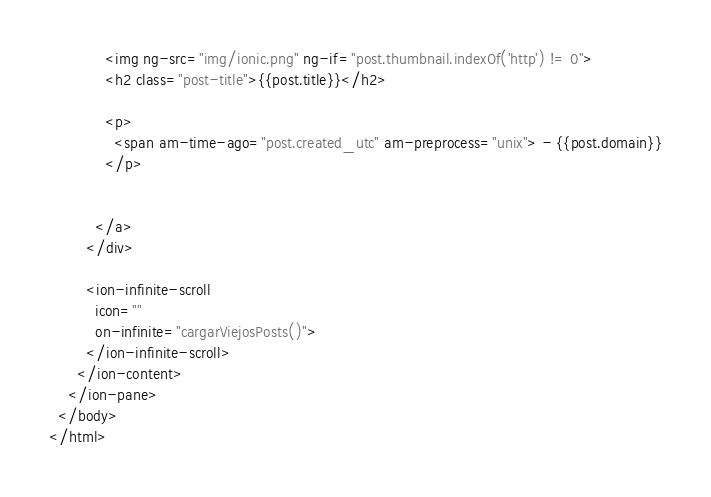<code> <loc_0><loc_0><loc_500><loc_500><_HTML_>            <img ng-src="img/ionic.png" ng-if="post.thumbnail.indexOf('http') != 0">
            <h2 class="post-title">{{post.title}}</h2>

            <p>
              <span am-time-ago="post.created_utc" am-preprocess="unix"> - {{post.domain}}
            </p>
          

          </a>
        </div>

        <ion-infinite-scroll 
          icon=""
          on-infinite="cargarViejosPosts()">
        </ion-infinite-scroll>
      </ion-content>
    </ion-pane>
  </body>
</html>
</code> 